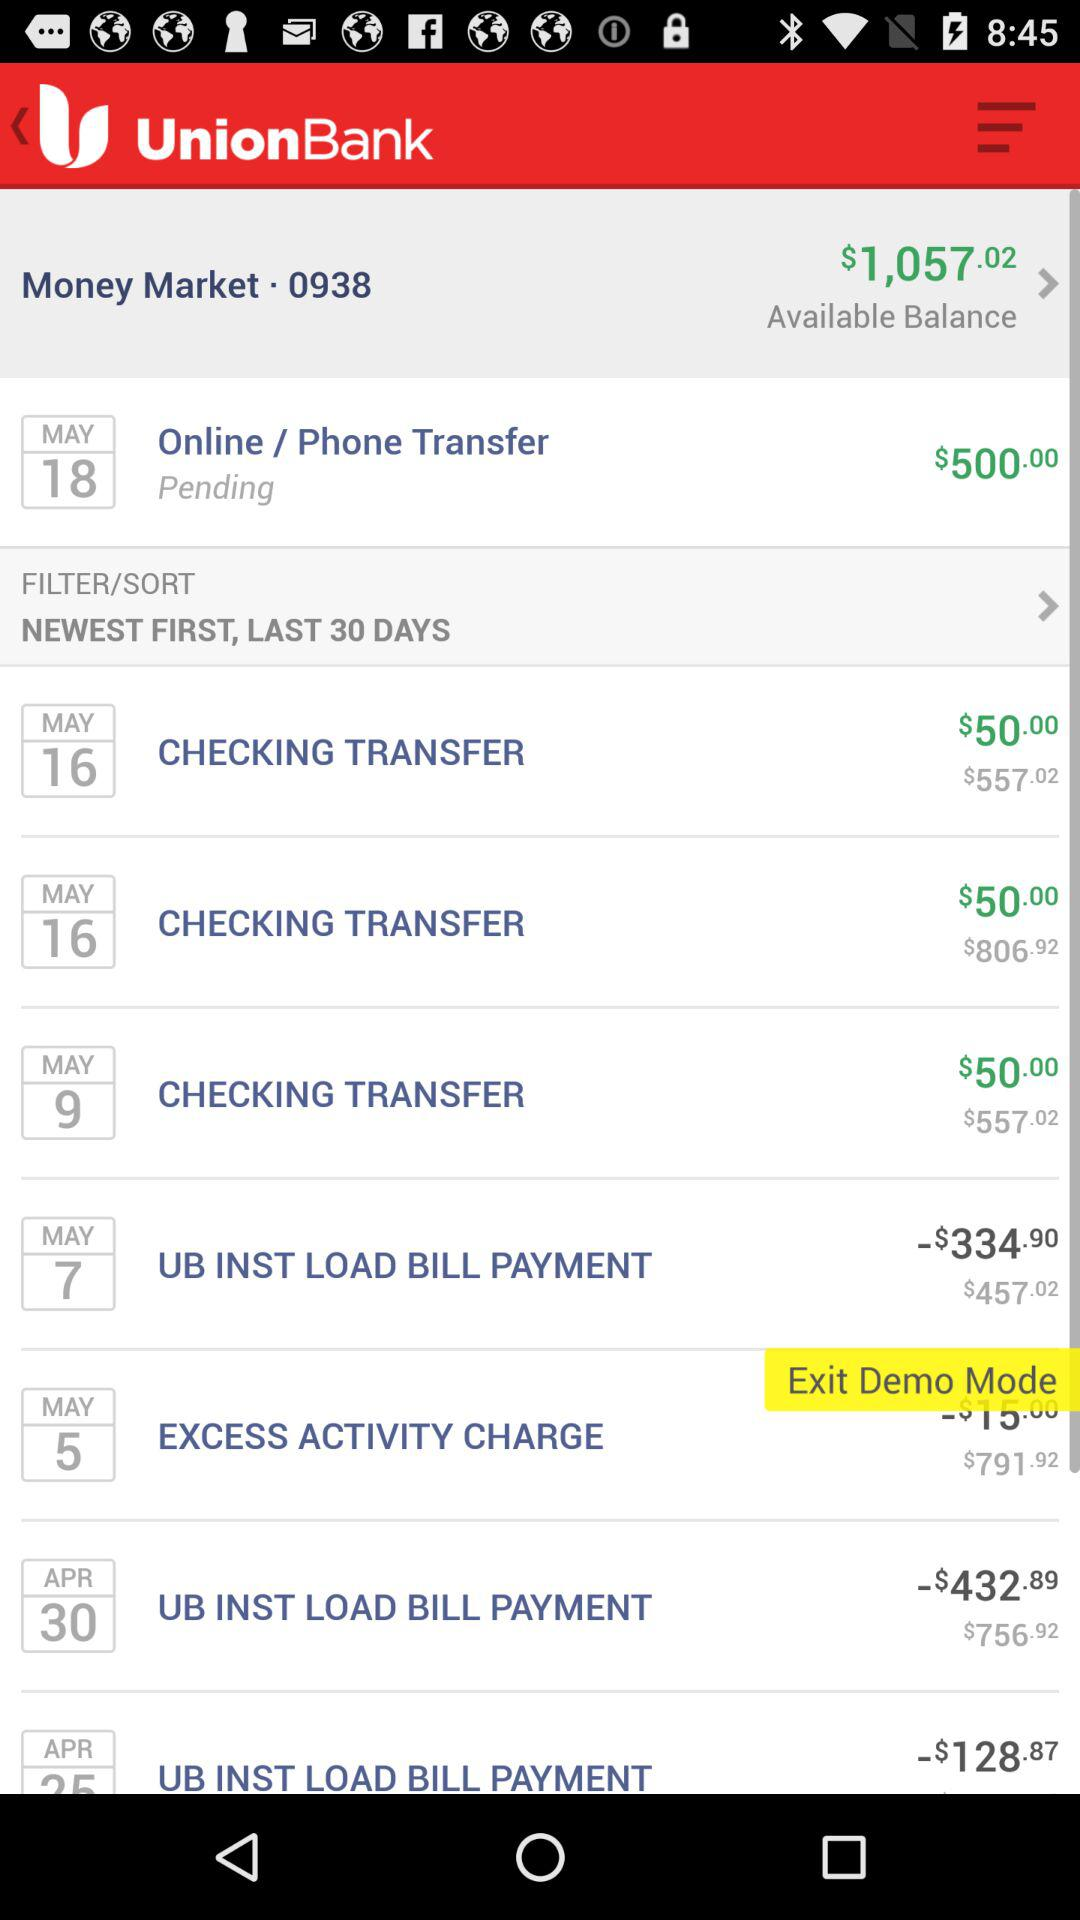For how many days are the last transactions shown? The transaction is shown for the last 30 days. 